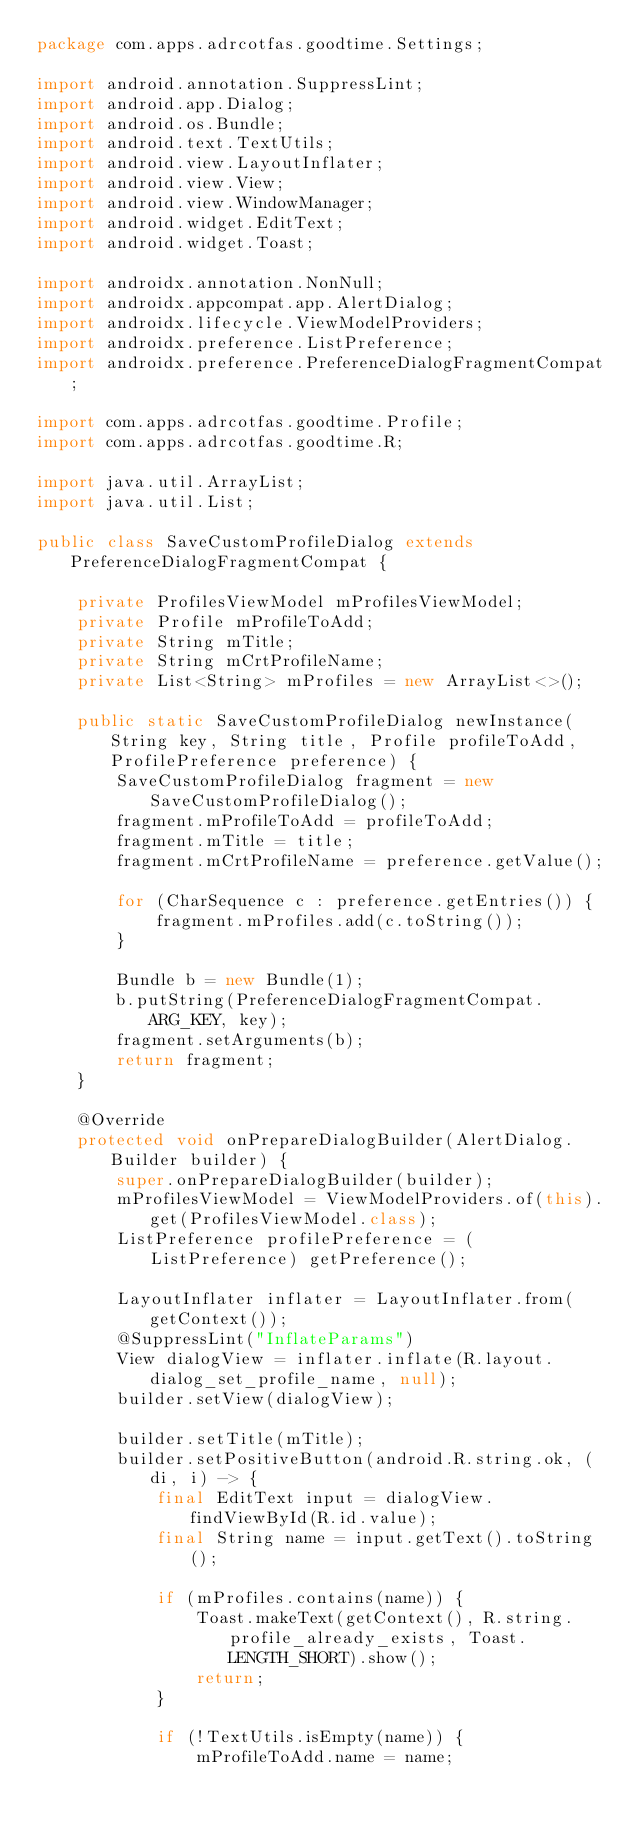Convert code to text. <code><loc_0><loc_0><loc_500><loc_500><_Java_>package com.apps.adrcotfas.goodtime.Settings;

import android.annotation.SuppressLint;
import android.app.Dialog;
import android.os.Bundle;
import android.text.TextUtils;
import android.view.LayoutInflater;
import android.view.View;
import android.view.WindowManager;
import android.widget.EditText;
import android.widget.Toast;

import androidx.annotation.NonNull;
import androidx.appcompat.app.AlertDialog;
import androidx.lifecycle.ViewModelProviders;
import androidx.preference.ListPreference;
import androidx.preference.PreferenceDialogFragmentCompat;

import com.apps.adrcotfas.goodtime.Profile;
import com.apps.adrcotfas.goodtime.R;

import java.util.ArrayList;
import java.util.List;

public class SaveCustomProfileDialog extends PreferenceDialogFragmentCompat {

    private ProfilesViewModel mProfilesViewModel;
    private Profile mProfileToAdd;
    private String mTitle;
    private String mCrtProfileName;
    private List<String> mProfiles = new ArrayList<>();

    public static SaveCustomProfileDialog newInstance(String key, String title, Profile profileToAdd, ProfilePreference preference) {
        SaveCustomProfileDialog fragment = new SaveCustomProfileDialog();
        fragment.mProfileToAdd = profileToAdd;
        fragment.mTitle = title;
        fragment.mCrtProfileName = preference.getValue();

        for (CharSequence c : preference.getEntries()) {
            fragment.mProfiles.add(c.toString());
        }

        Bundle b = new Bundle(1);
        b.putString(PreferenceDialogFragmentCompat.ARG_KEY, key);
        fragment.setArguments(b);
        return fragment;
    }

    @Override
    protected void onPrepareDialogBuilder(AlertDialog.Builder builder) {
        super.onPrepareDialogBuilder(builder);
        mProfilesViewModel = ViewModelProviders.of(this).get(ProfilesViewModel.class);
        ListPreference profilePreference = (ListPreference) getPreference();

        LayoutInflater inflater = LayoutInflater.from(getContext());
        @SuppressLint("InflateParams")
        View dialogView = inflater.inflate(R.layout.dialog_set_profile_name, null);
        builder.setView(dialogView);

        builder.setTitle(mTitle);
        builder.setPositiveButton(android.R.string.ok, (di, i) -> {
            final EditText input = dialogView.findViewById(R.id.value);
            final String name = input.getText().toString();

            if (mProfiles.contains(name)) {
                Toast.makeText(getContext(), R.string.profile_already_exists, Toast.LENGTH_SHORT).show();
                return;
            }

            if (!TextUtils.isEmpty(name)) {
                mProfileToAdd.name = name;</code> 